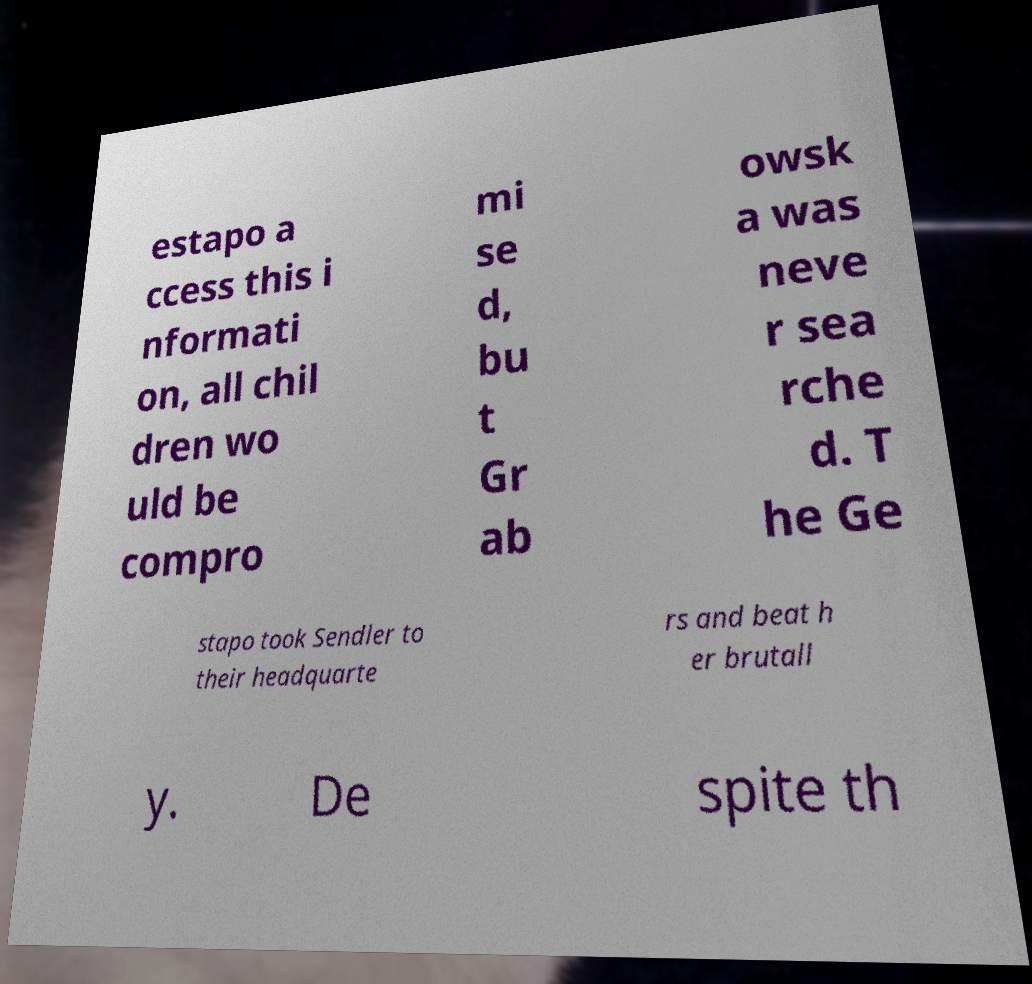Could you assist in decoding the text presented in this image and type it out clearly? estapo a ccess this i nformati on, all chil dren wo uld be compro mi se d, bu t Gr ab owsk a was neve r sea rche d. T he Ge stapo took Sendler to their headquarte rs and beat h er brutall y. De spite th 